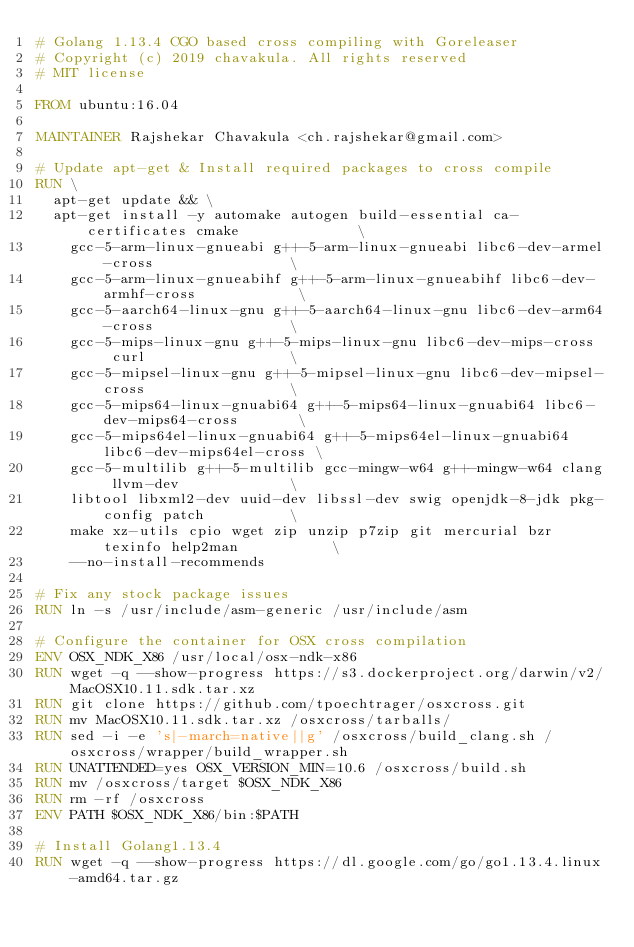Convert code to text. <code><loc_0><loc_0><loc_500><loc_500><_Dockerfile_># Golang 1.13.4 CGO based cross compiling with Goreleaser 
# Copyright (c) 2019 chavakula. All rights reserved
# MIT license

FROM ubuntu:16.04

MAINTAINER Rajshekar Chavakula <ch.rajshekar@gmail.com>

# Update apt-get & Install required packages to cross compile
RUN \
  apt-get update && \
  apt-get install -y automake autogen build-essential ca-certificates cmake              \
    gcc-5-arm-linux-gnueabi g++-5-arm-linux-gnueabi libc6-dev-armel-cross                \
    gcc-5-arm-linux-gnueabihf g++-5-arm-linux-gnueabihf libc6-dev-armhf-cross            \
    gcc-5-aarch64-linux-gnu g++-5-aarch64-linux-gnu libc6-dev-arm64-cross                \
    gcc-5-mips-linux-gnu g++-5-mips-linux-gnu libc6-dev-mips-cross  curl                 \
    gcc-5-mipsel-linux-gnu g++-5-mipsel-linux-gnu libc6-dev-mipsel-cross                 \
    gcc-5-mips64-linux-gnuabi64 g++-5-mips64-linux-gnuabi64 libc6-dev-mips64-cross       \
    gcc-5-mips64el-linux-gnuabi64 g++-5-mips64el-linux-gnuabi64 libc6-dev-mips64el-cross \
    gcc-5-multilib g++-5-multilib gcc-mingw-w64 g++-mingw-w64 clang llvm-dev             \
    libtool libxml2-dev uuid-dev libssl-dev swig openjdk-8-jdk pkg-config patch          \
    make xz-utils cpio wget zip unzip p7zip git mercurial bzr texinfo help2man           \
    --no-install-recommends

# Fix any stock package issues
RUN ln -s /usr/include/asm-generic /usr/include/asm

# Configure the container for OSX cross compilation
ENV OSX_NDK_X86 /usr/local/osx-ndk-x86
RUN wget -q --show-progress https://s3.dockerproject.org/darwin/v2/MacOSX10.11.sdk.tar.xz
RUN git clone https://github.com/tpoechtrager/osxcross.git
RUN mv MacOSX10.11.sdk.tar.xz /osxcross/tarballs/
RUN sed -i -e 's|-march=native||g' /osxcross/build_clang.sh /osxcross/wrapper/build_wrapper.sh
RUN UNATTENDED=yes OSX_VERSION_MIN=10.6 /osxcross/build.sh
RUN mv /osxcross/target $OSX_NDK_X86
RUN rm -rf /osxcross
ENV PATH $OSX_NDK_X86/bin:$PATH

# Install Golang1.13.4
RUN wget -q --show-progress https://dl.google.com/go/go1.13.4.linux-amd64.tar.gz</code> 